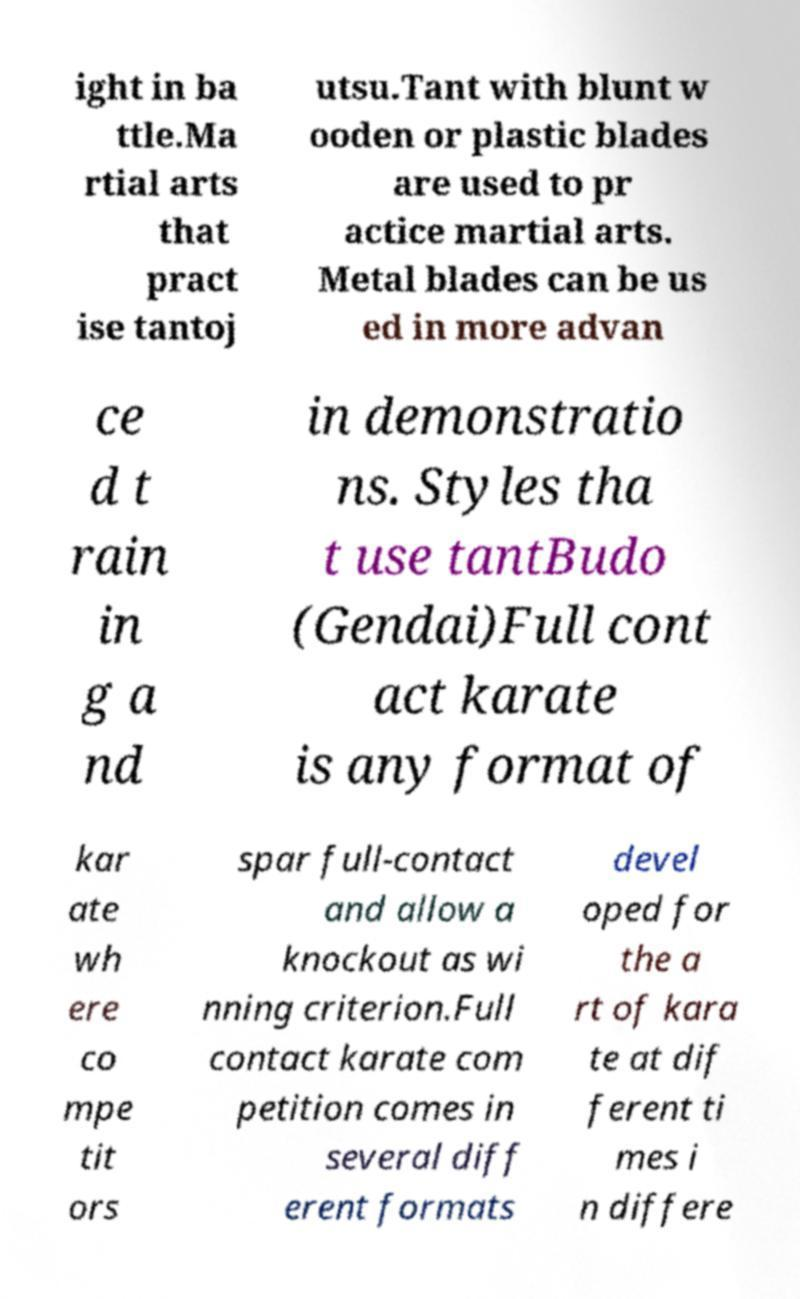Could you assist in decoding the text presented in this image and type it out clearly? ight in ba ttle.Ma rtial arts that pract ise tantoj utsu.Tant with blunt w ooden or plastic blades are used to pr actice martial arts. Metal blades can be us ed in more advan ce d t rain in g a nd in demonstratio ns. Styles tha t use tantBudo (Gendai)Full cont act karate is any format of kar ate wh ere co mpe tit ors spar full-contact and allow a knockout as wi nning criterion.Full contact karate com petition comes in several diff erent formats devel oped for the a rt of kara te at dif ferent ti mes i n differe 